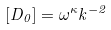<formula> <loc_0><loc_0><loc_500><loc_500>[ D _ { 0 } ] = \omega ^ { \kappa } k ^ { - 2 }</formula> 